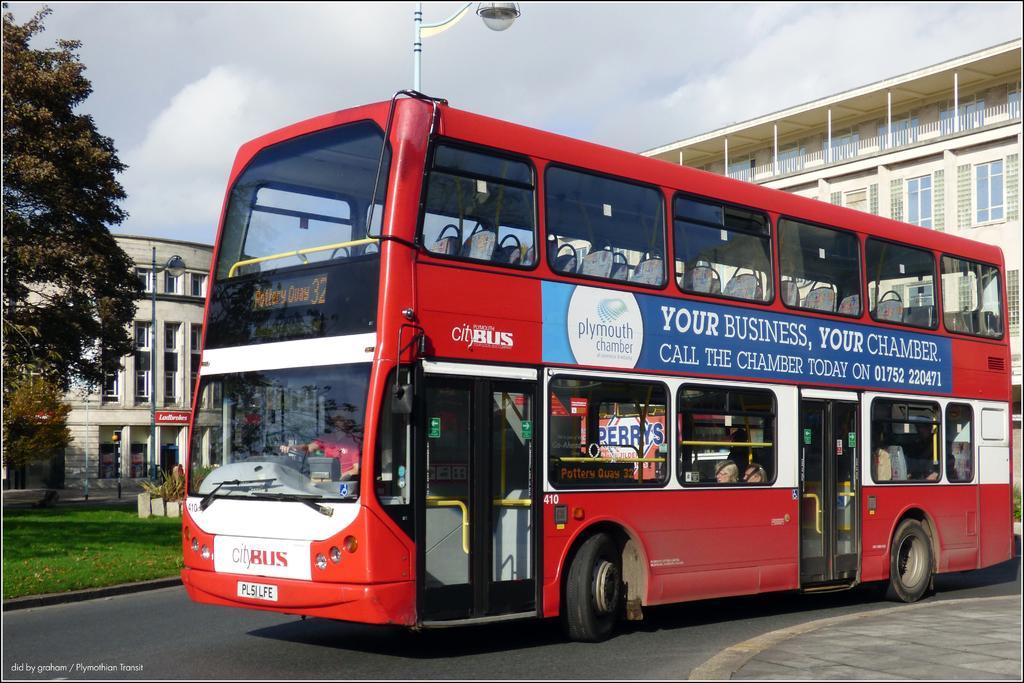Describe this image in one or two sentences. In this image, in the middle, we can see a bus which is moving on the road. In the bus, we can see a person riding it. On the right side, we can see a building, glass window. On the left side, we can see some trees, plants, street light, pole, building. In the background, we can also see a street light. At the top, we can see a sky, at the bottom, we can see a grass, road and a footpath. 